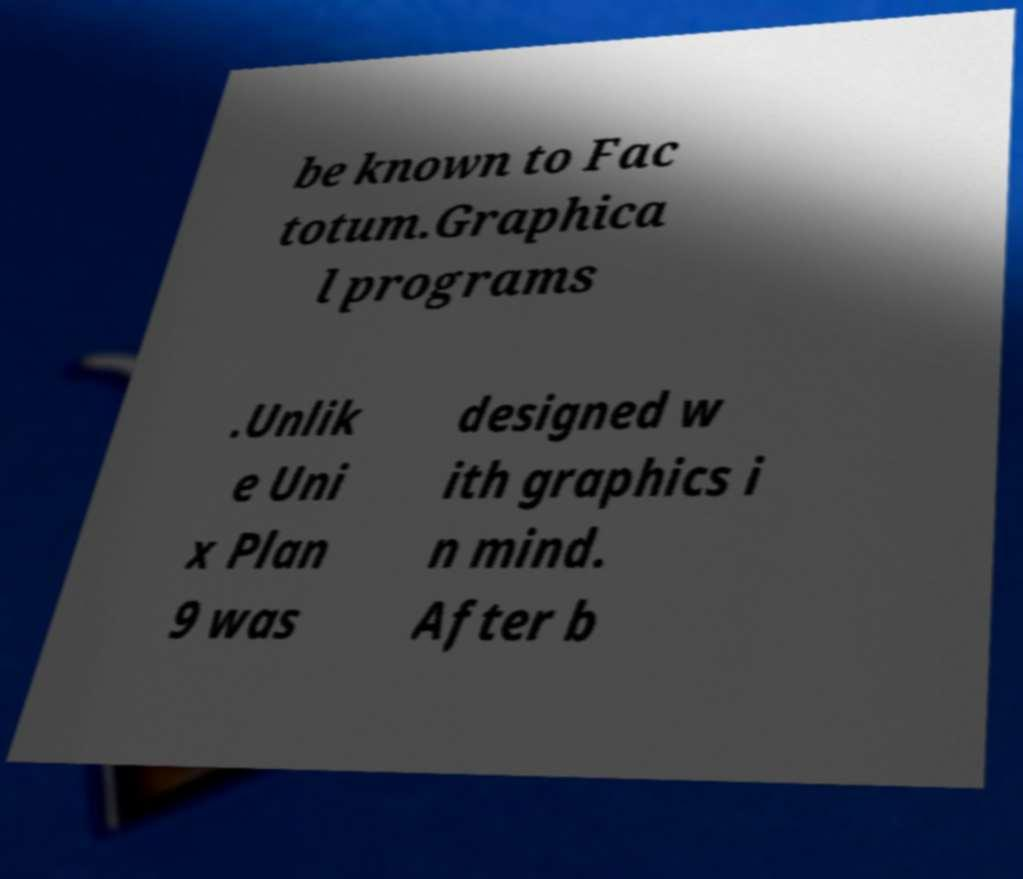Please read and relay the text visible in this image. What does it say? be known to Fac totum.Graphica l programs .Unlik e Uni x Plan 9 was designed w ith graphics i n mind. After b 